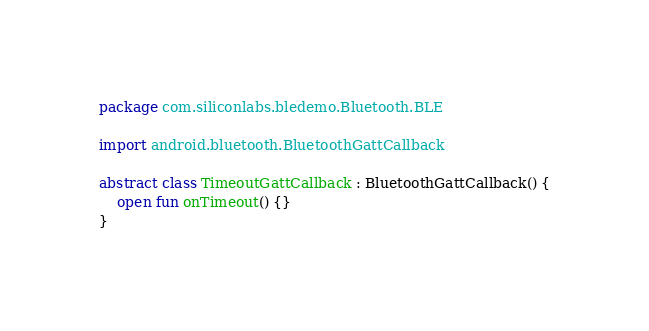Convert code to text. <code><loc_0><loc_0><loc_500><loc_500><_Kotlin_>package com.siliconlabs.bledemo.Bluetooth.BLE

import android.bluetooth.BluetoothGattCallback

abstract class TimeoutGattCallback : BluetoothGattCallback() {
    open fun onTimeout() {}
}</code> 